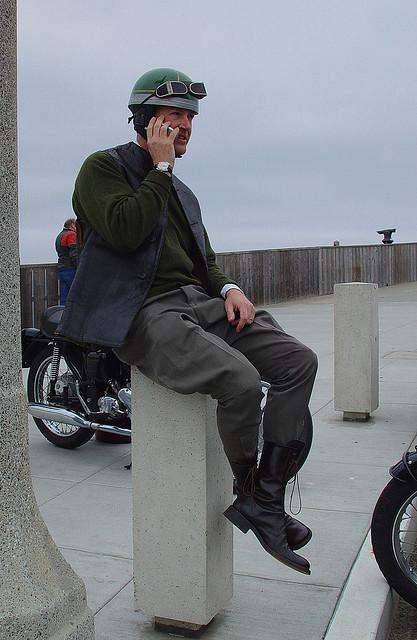The man sitting on the post with the phone to his ear is wearing what color of dome on his hat? Please explain your reasoning. green. Unless you are colorblind you can easily tell what color the helmet is. 